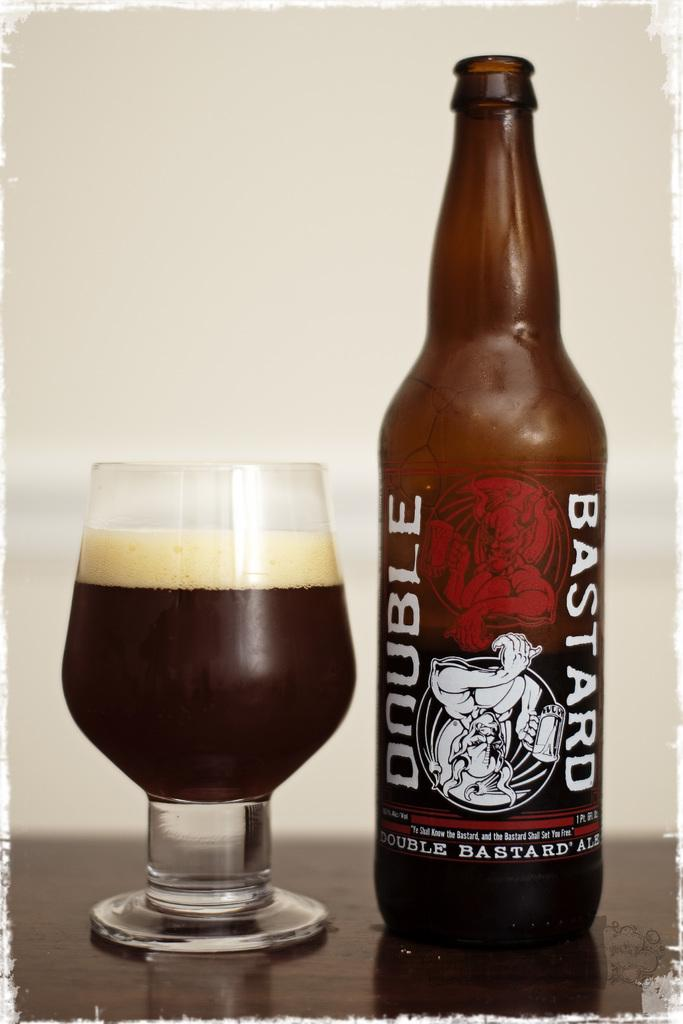Provide a one-sentence caption for the provided image. A bottle of double bastard ale that has been poured in a glass. 